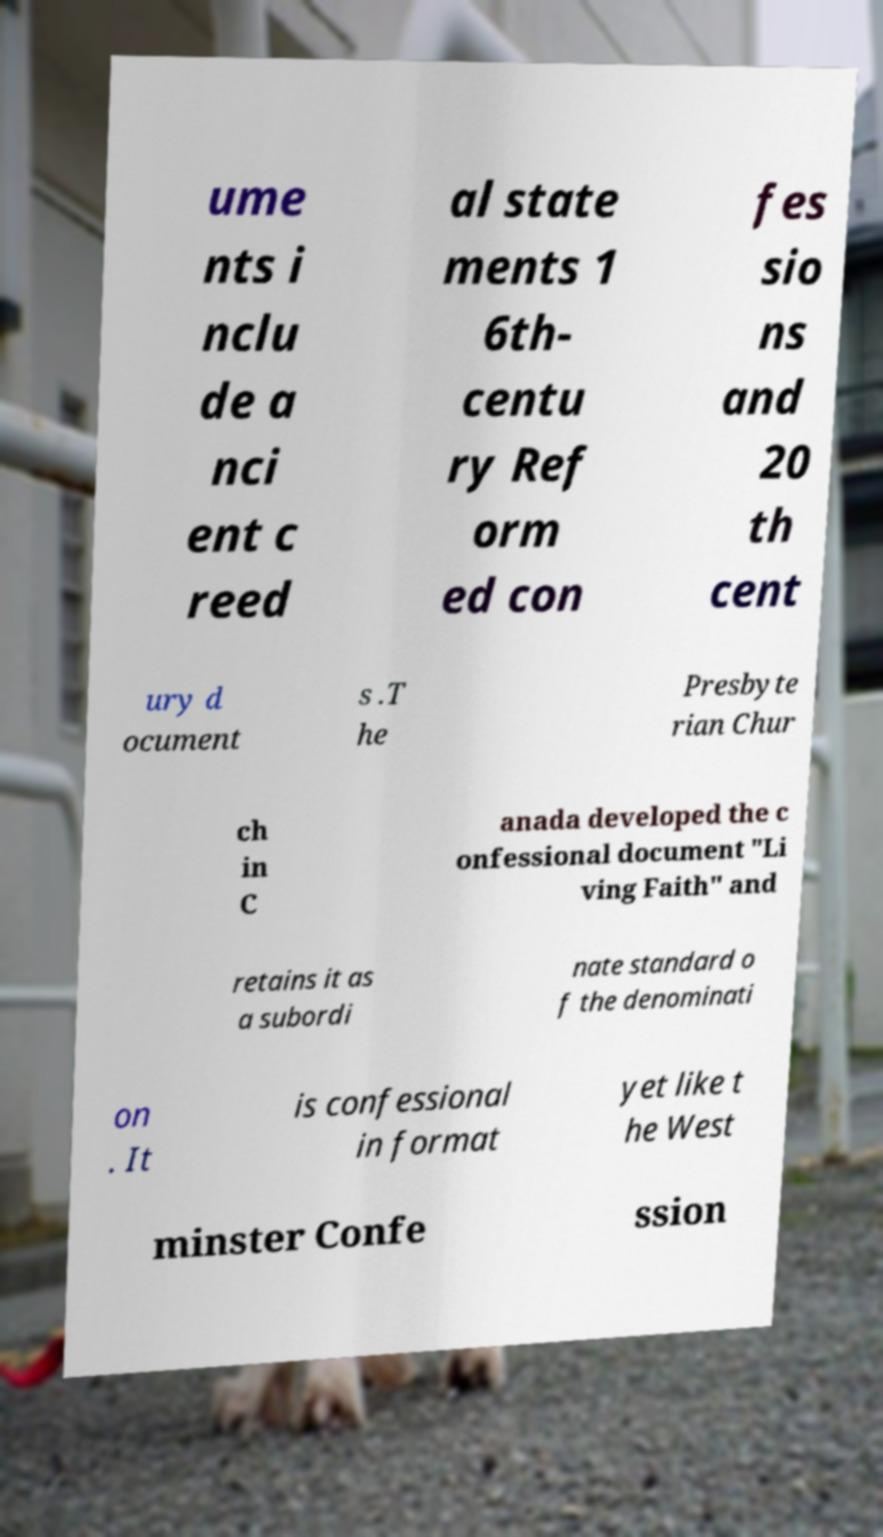Please read and relay the text visible in this image. What does it say? ume nts i nclu de a nci ent c reed al state ments 1 6th- centu ry Ref orm ed con fes sio ns and 20 th cent ury d ocument s .T he Presbyte rian Chur ch in C anada developed the c onfessional document "Li ving Faith" and retains it as a subordi nate standard o f the denominati on . It is confessional in format yet like t he West minster Confe ssion 